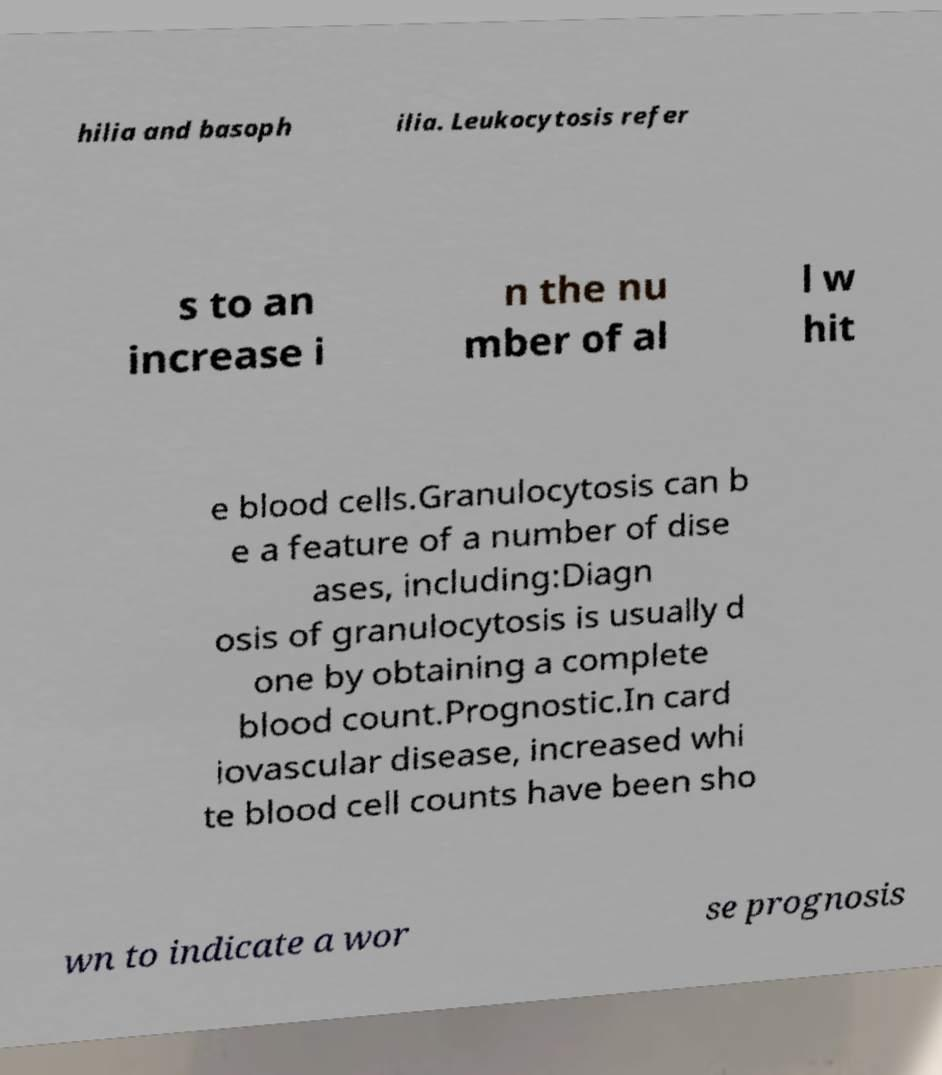I need the written content from this picture converted into text. Can you do that? hilia and basoph ilia. Leukocytosis refer s to an increase i n the nu mber of al l w hit e blood cells.Granulocytosis can b e a feature of a number of dise ases, including:Diagn osis of granulocytosis is usually d one by obtaining a complete blood count.Prognostic.In card iovascular disease, increased whi te blood cell counts have been sho wn to indicate a wor se prognosis 